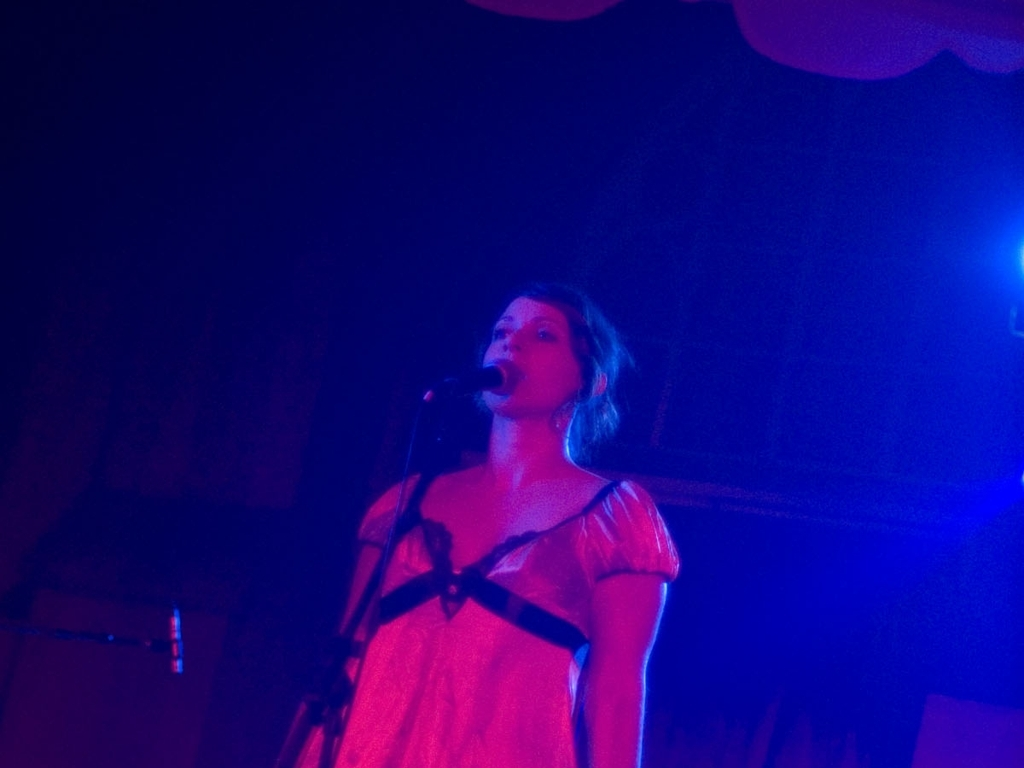What kind of emotional atmosphere does this image evoke? The warm lighting and the performer's serene expression may evoke a sense of intimacy and earnestness, as if the performer is deeply connected to the song or piece they are presenting. 